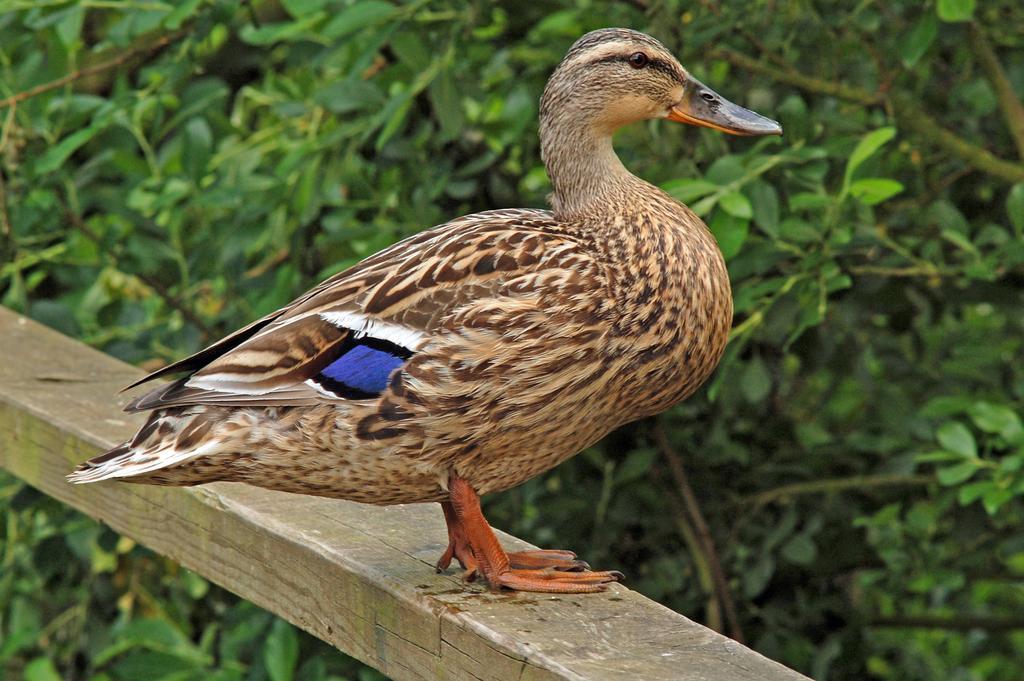Could you give a brief overview of what you see in this image? In this image, we can see a duck standing on the wooden pole. In the background, we can see leaves and stems. 